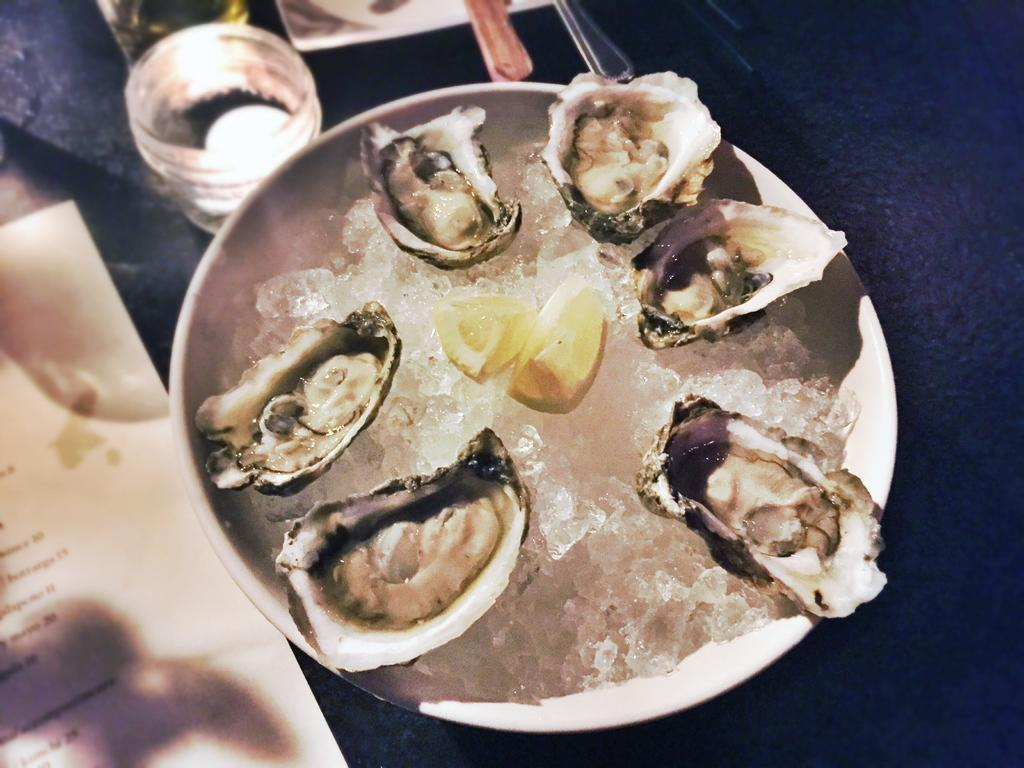What is on the plate that is visible in the image? The plate is filled with ice and lemon pieces. Are there any other food items on the plate? Yes, there are other food items on the plate. What is the glass in the image used for? The purpose of the glass in the image is not specified, but it could be used for drinking. What is the paper in the image used for? The purpose of the paper in the image is not specified, but it could be used for writing or wrapping. What type of prison can be seen in the image? There is no prison present in the image; it features a plate with ice, lemon pieces, and other food items, along with a glass and paper. 